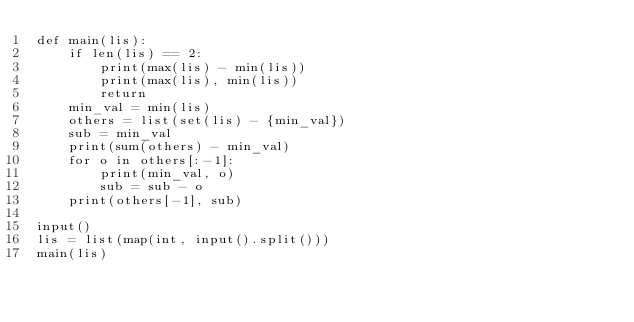Convert code to text. <code><loc_0><loc_0><loc_500><loc_500><_Python_>def main(lis):
    if len(lis) == 2:
        print(max(lis) - min(lis))
        print(max(lis), min(lis))
        return
    min_val = min(lis)
    others = list(set(lis) - {min_val})
    sub = min_val
    print(sum(others) - min_val)
    for o in others[:-1]:
        print(min_val, o)
        sub = sub - o
    print(others[-1], sub)

input()
lis = list(map(int, input().split()))
main(lis)
</code> 